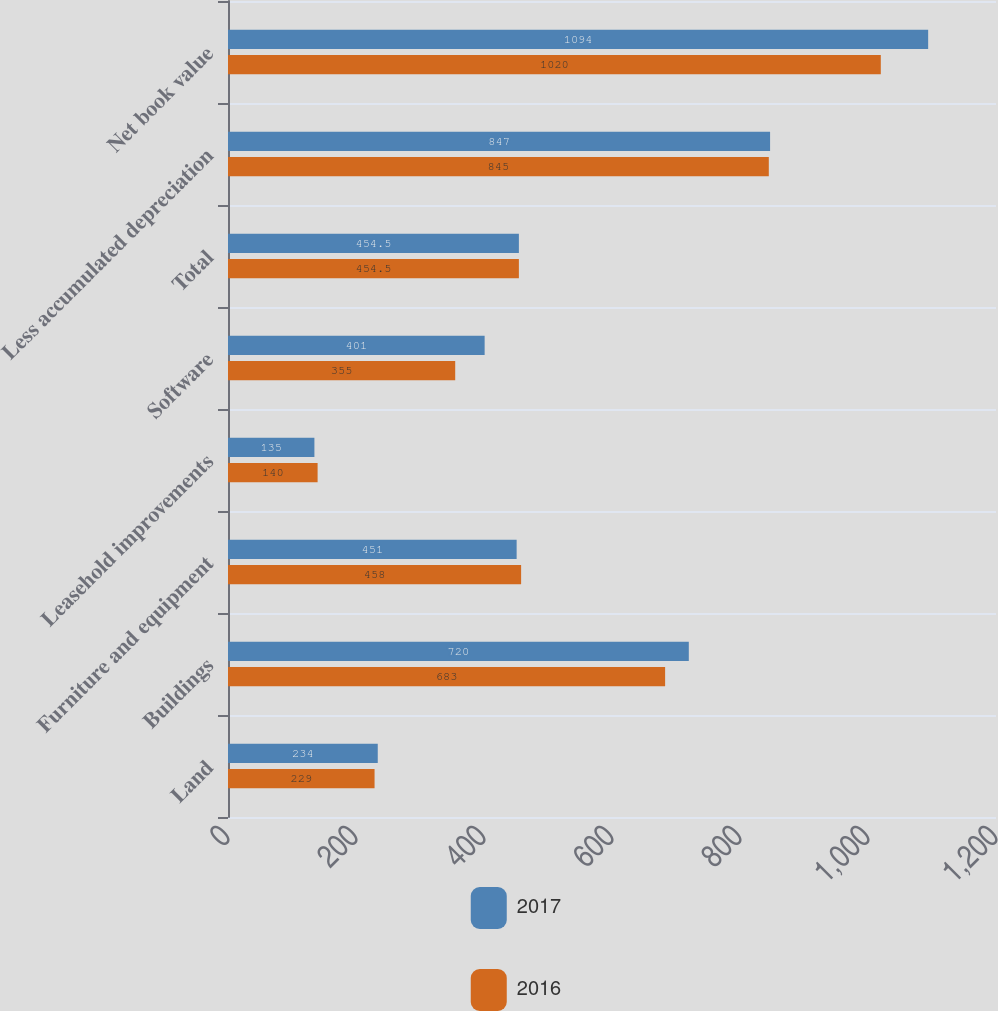<chart> <loc_0><loc_0><loc_500><loc_500><stacked_bar_chart><ecel><fcel>Land<fcel>Buildings<fcel>Furniture and equipment<fcel>Leasehold improvements<fcel>Software<fcel>Total<fcel>Less accumulated depreciation<fcel>Net book value<nl><fcel>2017<fcel>234<fcel>720<fcel>451<fcel>135<fcel>401<fcel>454.5<fcel>847<fcel>1094<nl><fcel>2016<fcel>229<fcel>683<fcel>458<fcel>140<fcel>355<fcel>454.5<fcel>845<fcel>1020<nl></chart> 